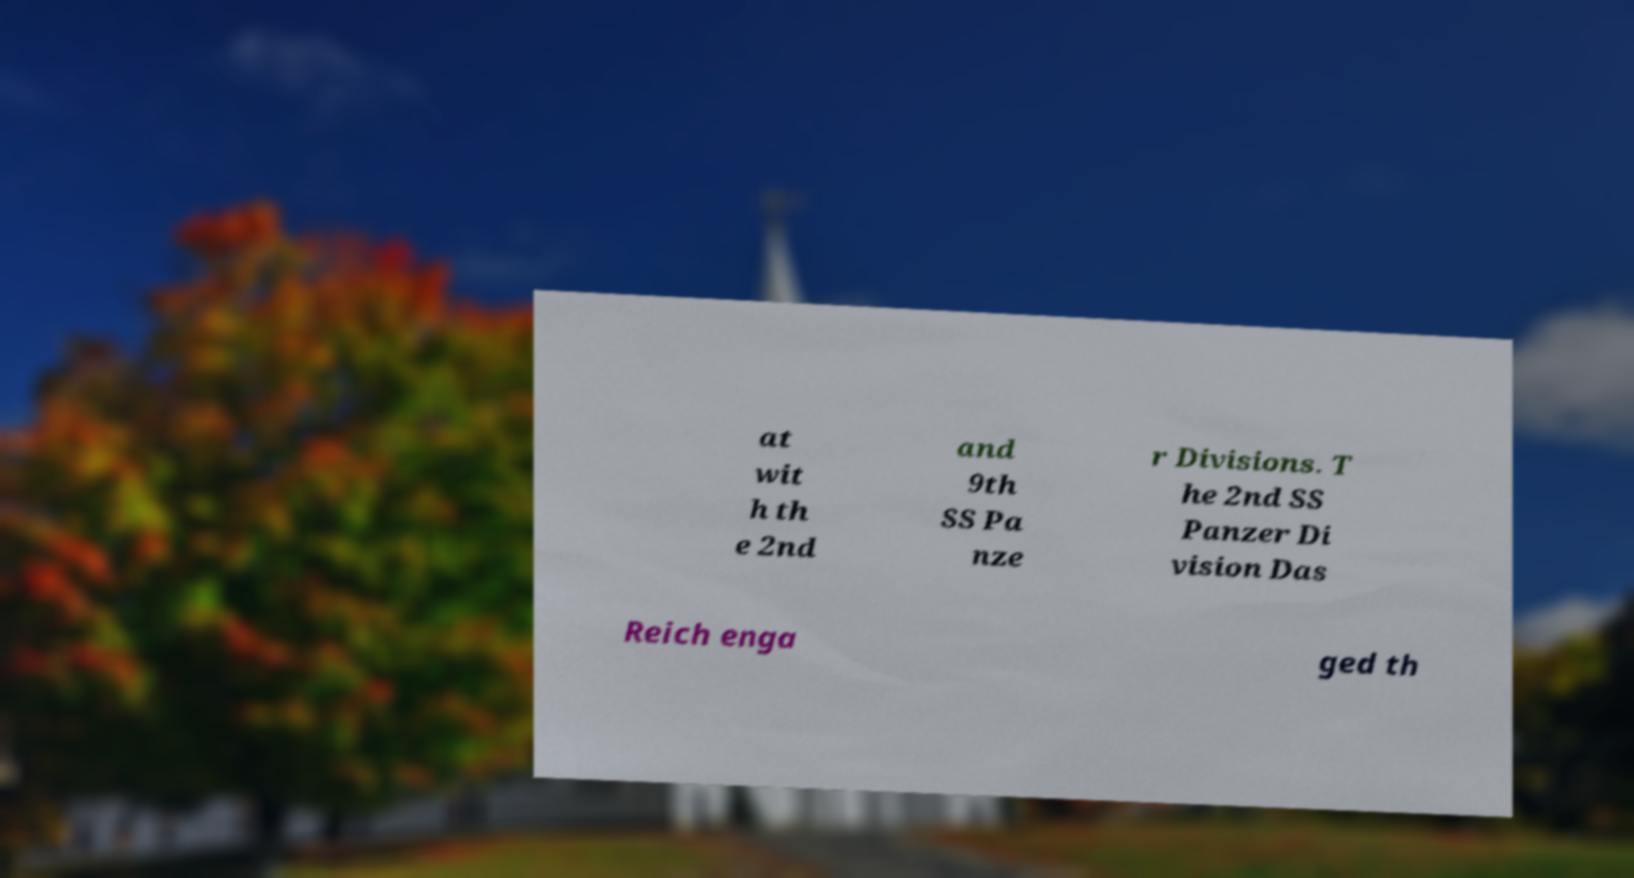Could you extract and type out the text from this image? at wit h th e 2nd and 9th SS Pa nze r Divisions. T he 2nd SS Panzer Di vision Das Reich enga ged th 